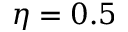Convert formula to latex. <formula><loc_0><loc_0><loc_500><loc_500>\eta = 0 . 5</formula> 